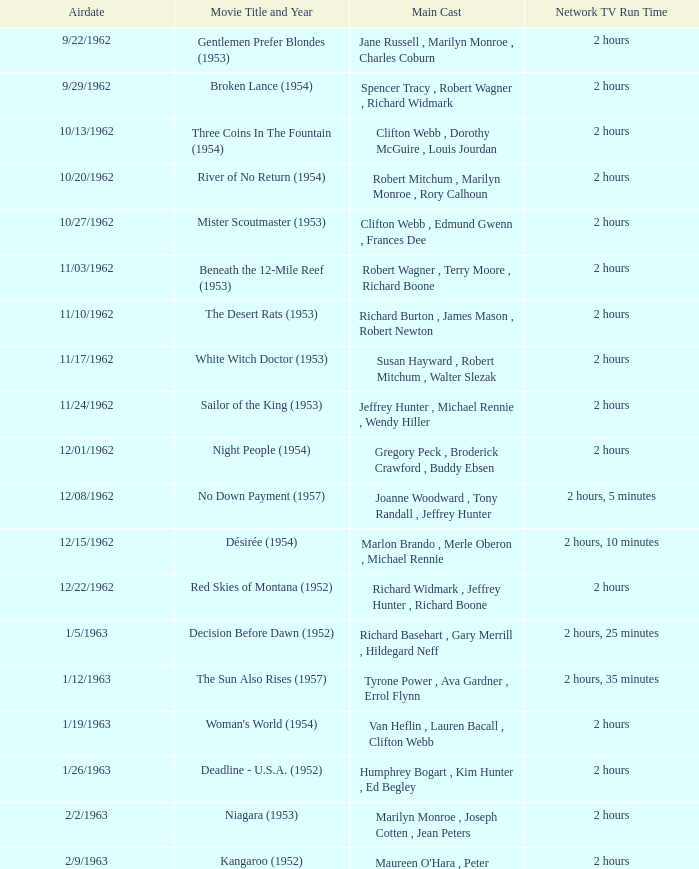How many runtimes does episode 53 have? 1.0. 